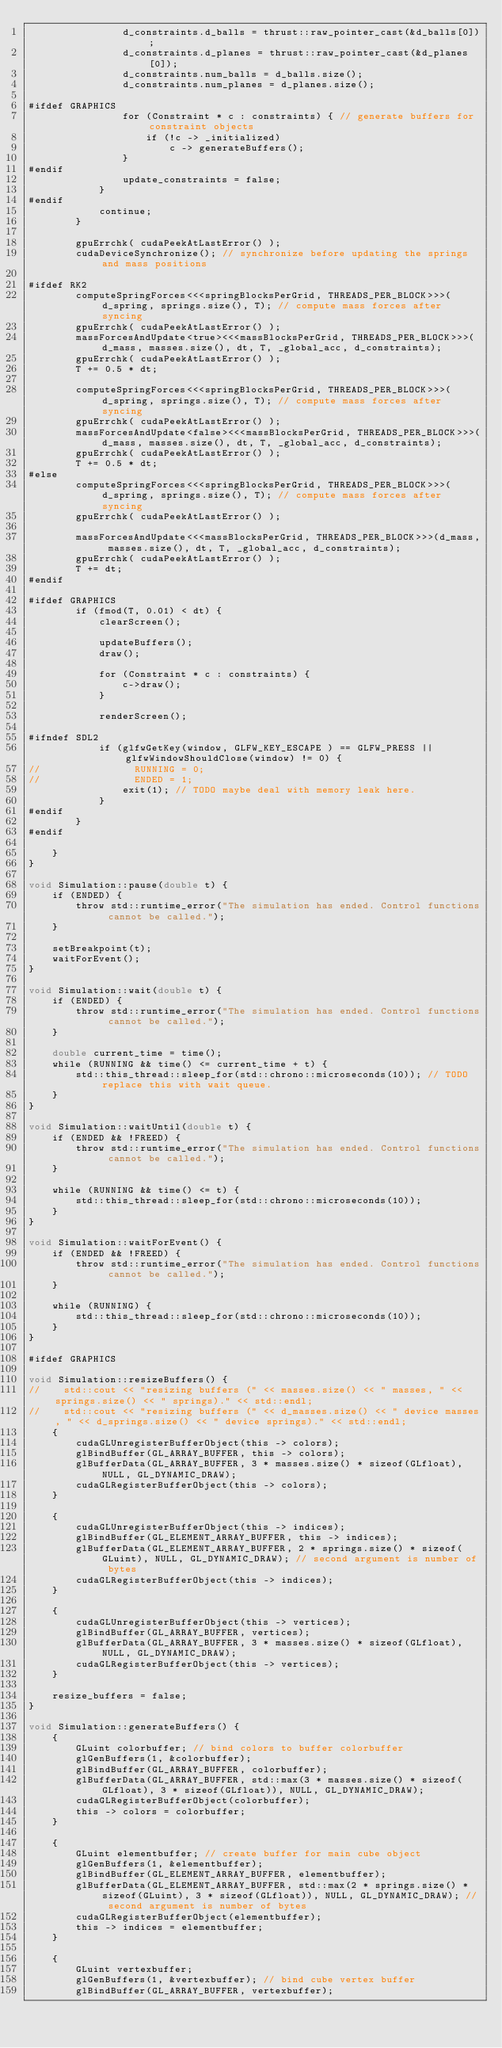<code> <loc_0><loc_0><loc_500><loc_500><_Cuda_>                d_constraints.d_balls = thrust::raw_pointer_cast(&d_balls[0]);
                d_constraints.d_planes = thrust::raw_pointer_cast(&d_planes[0]);
                d_constraints.num_balls = d_balls.size();
                d_constraints.num_planes = d_planes.size();

#ifdef GRAPHICS
                for (Constraint * c : constraints) { // generate buffers for constraint objects
                    if (!c -> _initialized)
                        c -> generateBuffers();
                }
#endif
                update_constraints = false;
            }
#endif
            continue;
        }

        gpuErrchk( cudaPeekAtLastError() );
        cudaDeviceSynchronize(); // synchronize before updating the springs and mass positions
                
#ifdef RK2
        computeSpringForces<<<springBlocksPerGrid, THREADS_PER_BLOCK>>>(d_spring, springs.size(), T); // compute mass forces after syncing
        gpuErrchk( cudaPeekAtLastError() );
        massForcesAndUpdate<true><<<massBlocksPerGrid, THREADS_PER_BLOCK>>>(d_mass, masses.size(), dt, T, _global_acc, d_constraints);
        gpuErrchk( cudaPeekAtLastError() );
        T += 0.5 * dt;

        computeSpringForces<<<springBlocksPerGrid, THREADS_PER_BLOCK>>>(d_spring, springs.size(), T); // compute mass forces after syncing
        gpuErrchk( cudaPeekAtLastError() );
        massForcesAndUpdate<false><<<massBlocksPerGrid, THREADS_PER_BLOCK>>>(d_mass, masses.size(), dt, T, _global_acc, d_constraints);
        gpuErrchk( cudaPeekAtLastError() );
        T += 0.5 * dt;
#else
        computeSpringForces<<<springBlocksPerGrid, THREADS_PER_BLOCK>>>(d_spring, springs.size(), T); // compute mass forces after syncing
        gpuErrchk( cudaPeekAtLastError() );

        massForcesAndUpdate<<<massBlocksPerGrid, THREADS_PER_BLOCK>>>(d_mass, masses.size(), dt, T, _global_acc, d_constraints);
        gpuErrchk( cudaPeekAtLastError() );
        T += dt;
#endif

#ifdef GRAPHICS
        if (fmod(T, 0.01) < dt) {
            clearScreen();

            updateBuffers();
            draw();

            for (Constraint * c : constraints) {
                c->draw();
            }

            renderScreen();

#ifndef SDL2
            if (glfwGetKey(window, GLFW_KEY_ESCAPE ) == GLFW_PRESS || glfwWindowShouldClose(window) != 0) {
//                RUNNING = 0;
//                ENDED = 1;
                exit(1); // TODO maybe deal with memory leak here.
            }
#endif
        }
#endif

    }
}

void Simulation::pause(double t) {
    if (ENDED) {
        throw std::runtime_error("The simulation has ended. Control functions cannot be called.");
    }

    setBreakpoint(t);
    waitForEvent();
}

void Simulation::wait(double t) {
    if (ENDED) {
        throw std::runtime_error("The simulation has ended. Control functions cannot be called.");
    }

    double current_time = time();
    while (RUNNING && time() <= current_time + t) {
        std::this_thread::sleep_for(std::chrono::microseconds(10)); // TODO replace this with wait queue. 
    }
}

void Simulation::waitUntil(double t) {
    if (ENDED && !FREED) {
        throw std::runtime_error("The simulation has ended. Control functions cannot be called.");
    }

    while (RUNNING && time() <= t) {
        std::this_thread::sleep_for(std::chrono::microseconds(10));
    }
}

void Simulation::waitForEvent() {
    if (ENDED && !FREED) {
        throw std::runtime_error("The simulation has ended. Control functions cannot be called.");
    }

    while (RUNNING) {
        std::this_thread::sleep_for(std::chrono::microseconds(10));
    }
}

#ifdef GRAPHICS

void Simulation::resizeBuffers() {
//    std::cout << "resizing buffers (" << masses.size() << " masses, " << springs.size() << " springs)." << std::endl;
//    std::cout << "resizing buffers (" << d_masses.size() << " device masses, " << d_springs.size() << " device springs)." << std::endl;
    {
        cudaGLUnregisterBufferObject(this -> colors);
        glBindBuffer(GL_ARRAY_BUFFER, this -> colors);
        glBufferData(GL_ARRAY_BUFFER, 3 * masses.size() * sizeof(GLfloat), NULL, GL_DYNAMIC_DRAW);
        cudaGLRegisterBufferObject(this -> colors);
    }

    {
        cudaGLUnregisterBufferObject(this -> indices);
        glBindBuffer(GL_ELEMENT_ARRAY_BUFFER, this -> indices);
        glBufferData(GL_ELEMENT_ARRAY_BUFFER, 2 * springs.size() * sizeof(GLuint), NULL, GL_DYNAMIC_DRAW); // second argument is number of bytes
        cudaGLRegisterBufferObject(this -> indices);
    }

    {
        cudaGLUnregisterBufferObject(this -> vertices);
        glBindBuffer(GL_ARRAY_BUFFER, vertices);
        glBufferData(GL_ARRAY_BUFFER, 3 * masses.size() * sizeof(GLfloat), NULL, GL_DYNAMIC_DRAW);
        cudaGLRegisterBufferObject(this -> vertices);
    }

    resize_buffers = false;
}

void Simulation::generateBuffers() {
    {
        GLuint colorbuffer; // bind colors to buffer colorbuffer
        glGenBuffers(1, &colorbuffer);
        glBindBuffer(GL_ARRAY_BUFFER, colorbuffer);
        glBufferData(GL_ARRAY_BUFFER, std::max(3 * masses.size() * sizeof(GLfloat), 3 * sizeof(GLfloat)), NULL, GL_DYNAMIC_DRAW);
        cudaGLRegisterBufferObject(colorbuffer);
        this -> colors = colorbuffer;
    }

    {
        GLuint elementbuffer; // create buffer for main cube object
        glGenBuffers(1, &elementbuffer);
        glBindBuffer(GL_ELEMENT_ARRAY_BUFFER, elementbuffer);
        glBufferData(GL_ELEMENT_ARRAY_BUFFER, std::max(2 * springs.size() * sizeof(GLuint), 3 * sizeof(GLfloat)), NULL, GL_DYNAMIC_DRAW); // second argument is number of bytes
        cudaGLRegisterBufferObject(elementbuffer);
        this -> indices = elementbuffer;
    }

    {
        GLuint vertexbuffer;
        glGenBuffers(1, &vertexbuffer); // bind cube vertex buffer
        glBindBuffer(GL_ARRAY_BUFFER, vertexbuffer);</code> 